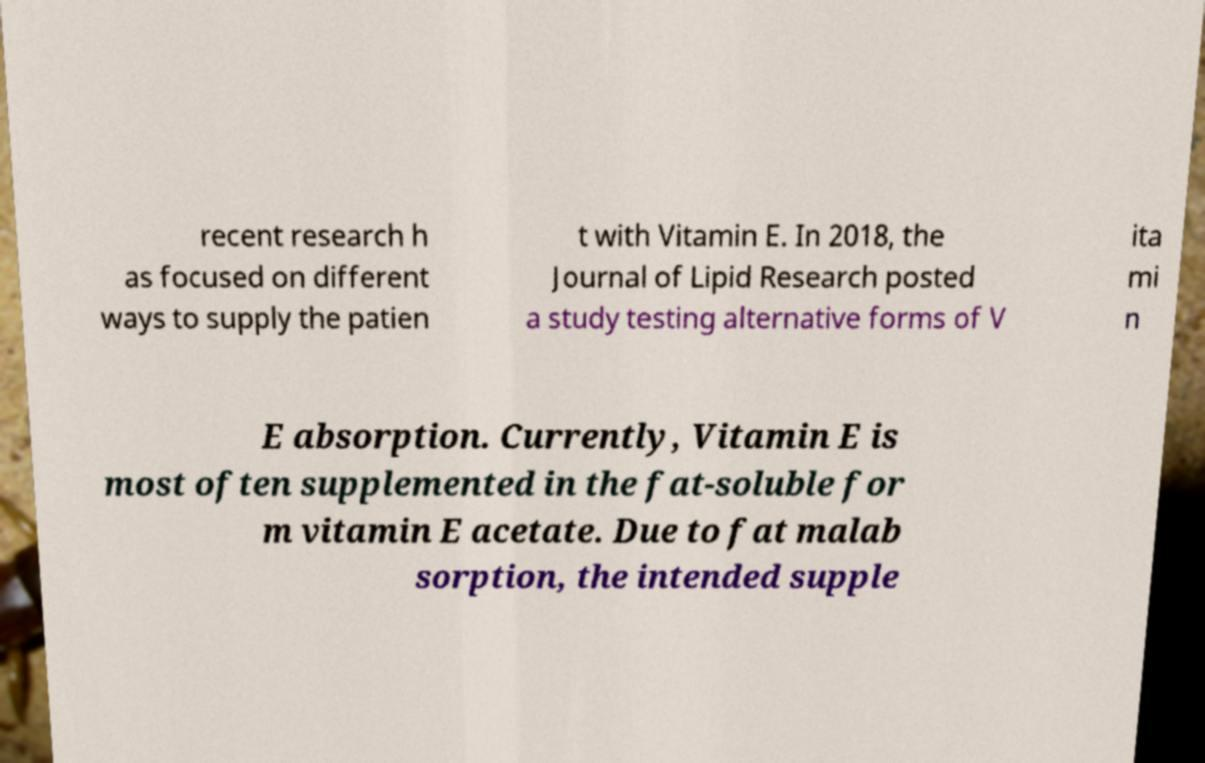Please identify and transcribe the text found in this image. recent research h as focused on different ways to supply the patien t with Vitamin E. In 2018, the Journal of Lipid Research posted a study testing alternative forms of V ita mi n E absorption. Currently, Vitamin E is most often supplemented in the fat-soluble for m vitamin E acetate. Due to fat malab sorption, the intended supple 